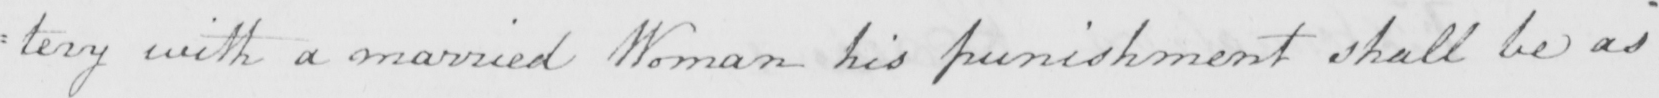What text is written in this handwritten line? : tery with a married Woman his punishment shall be as 